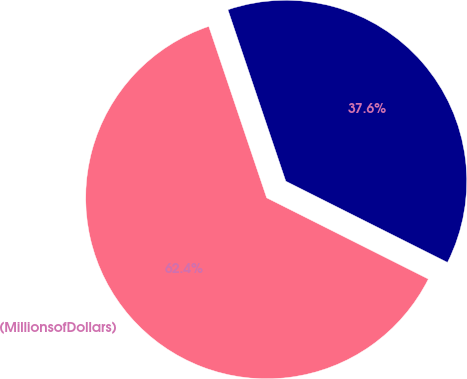Convert chart. <chart><loc_0><loc_0><loc_500><loc_500><pie_chart><fcel>(MillionsofDollars)<fcel>Unnamed: 1<nl><fcel>62.41%<fcel>37.59%<nl></chart> 